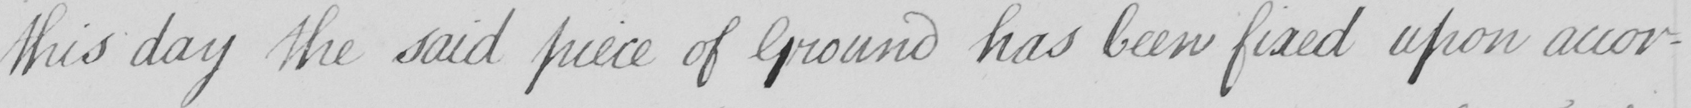Can you tell me what this handwritten text says? this day the said piece of Ground has been fixed upon accor- 